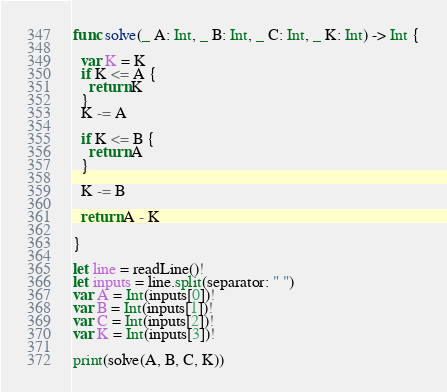<code> <loc_0><loc_0><loc_500><loc_500><_Swift_>func solve(_ A: Int, _ B: Int, _ C: Int, _ K: Int) -> Int {
  
  var K = K
  if K <= A {
    return K
  }
  K -= A
  
  if K <= B {
    return A
  }
  
  K -= B
  
  return A - K
  
}

let line = readLine()!
let inputs = line.split(separator: " ")
var A = Int(inputs[0])!
var B = Int(inputs[1])!
var C = Int(inputs[2])!
var K = Int(inputs[3])!

print(solve(A, B, C, K))</code> 